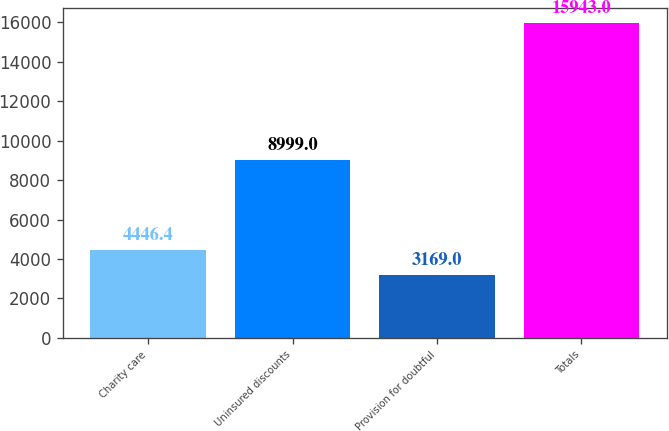Convert chart to OTSL. <chart><loc_0><loc_0><loc_500><loc_500><bar_chart><fcel>Charity care<fcel>Uninsured discounts<fcel>Provision for doubtful<fcel>Totals<nl><fcel>4446.4<fcel>8999<fcel>3169<fcel>15943<nl></chart> 